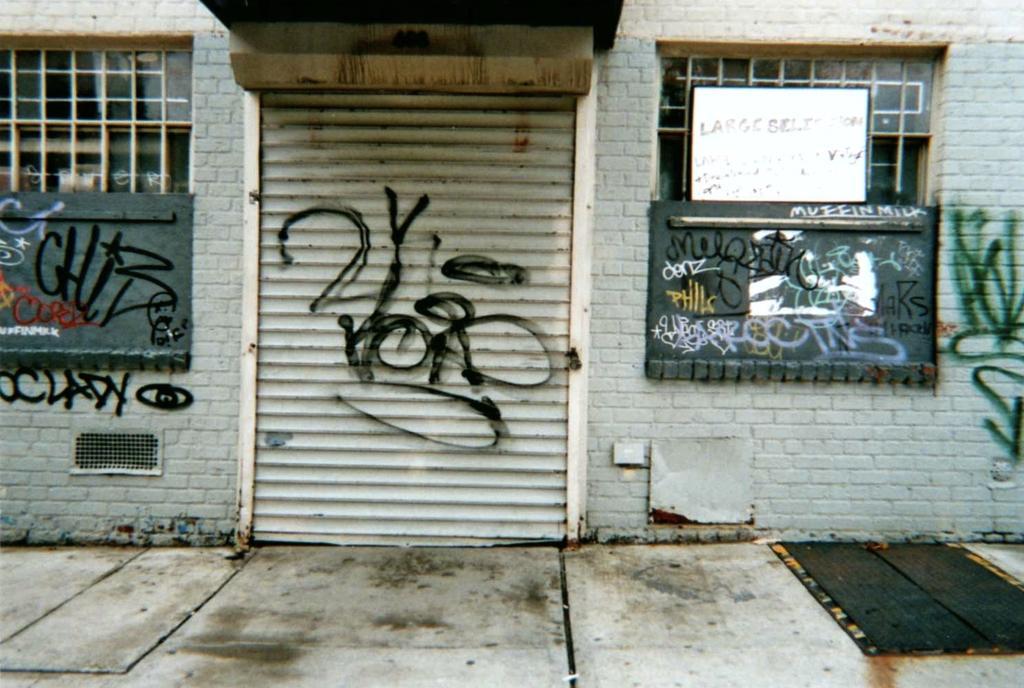Could you give a brief overview of what you see in this image? In this image we can see there is a wall with shutter. And there are boards with text and painting. In front of the wall we can see the ground. And at the top there is the wood. 